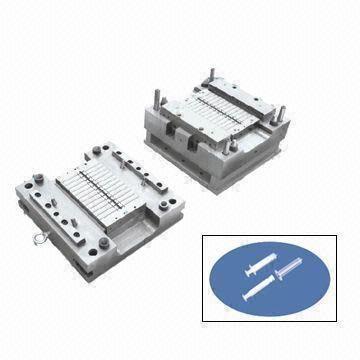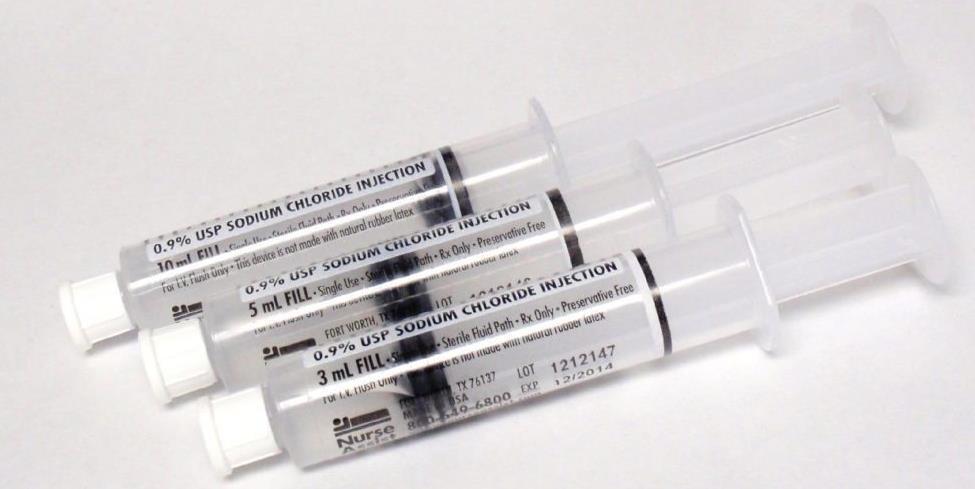The first image is the image on the left, the second image is the image on the right. For the images shown, is this caption "3 syringes are pointed to the left." true? Answer yes or no. Yes. 